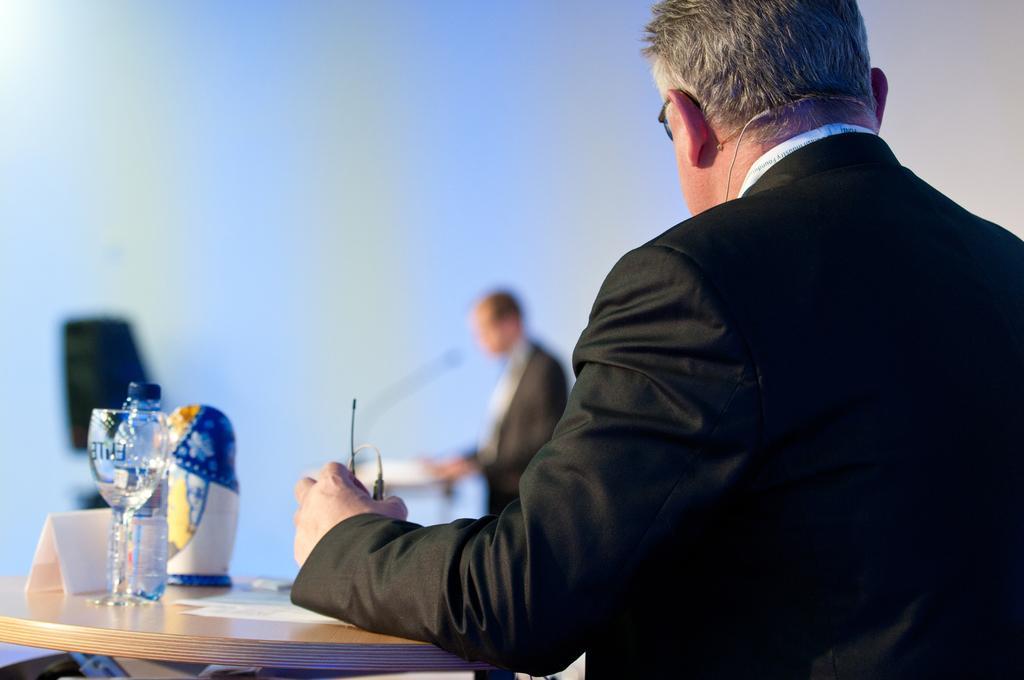Describe this image in one or two sentences. In this image there are two persons wearing black suits and at the right side of the image there is a person who is looking behind holding a microphone in his left hand and at the left side of the image there is a glass and bottle which is placed on the table and the behind there is a person who is speaking 